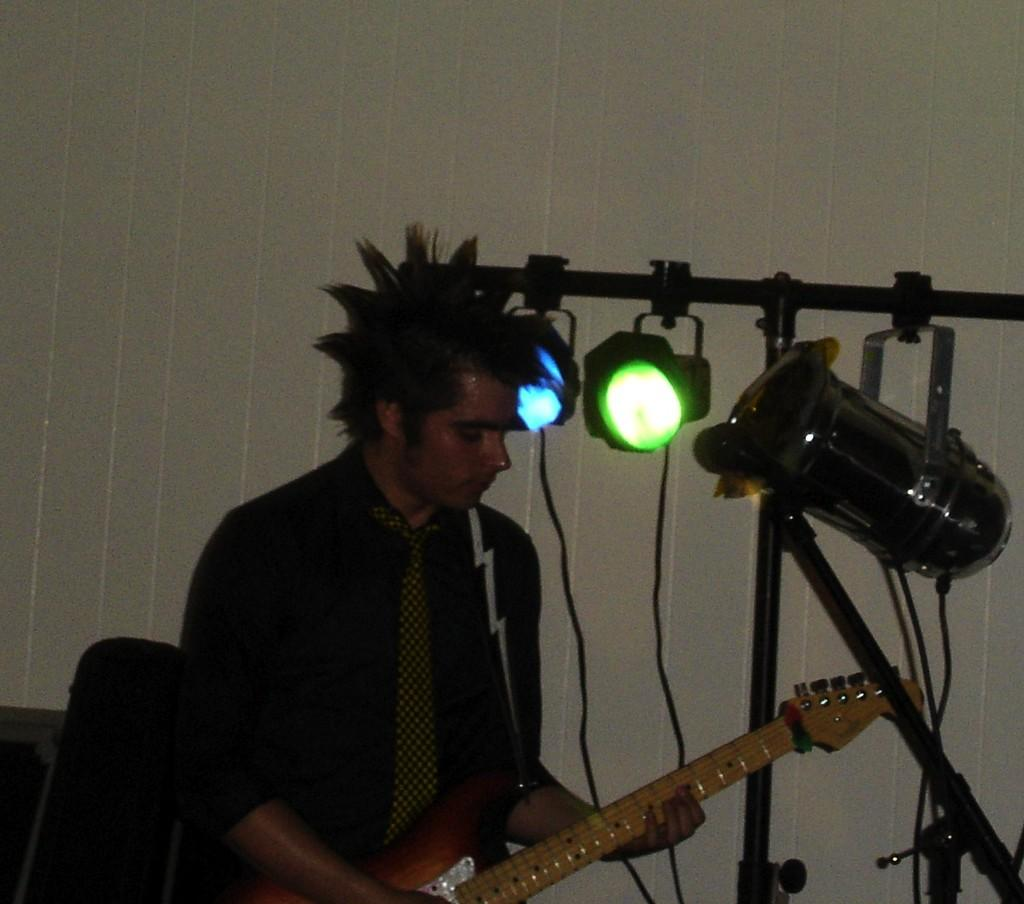What is the man in the image doing? The man is playing a guitar in the image. What can be seen in the background of the image? There is a wall in the background of the image. What else is visible in the image besides the man and the wall? There are lights visible in the image. What force is being applied to the guitar by the man in the image? There is no specific force mentioned or visible in the image; the man is simply playing the guitar. 